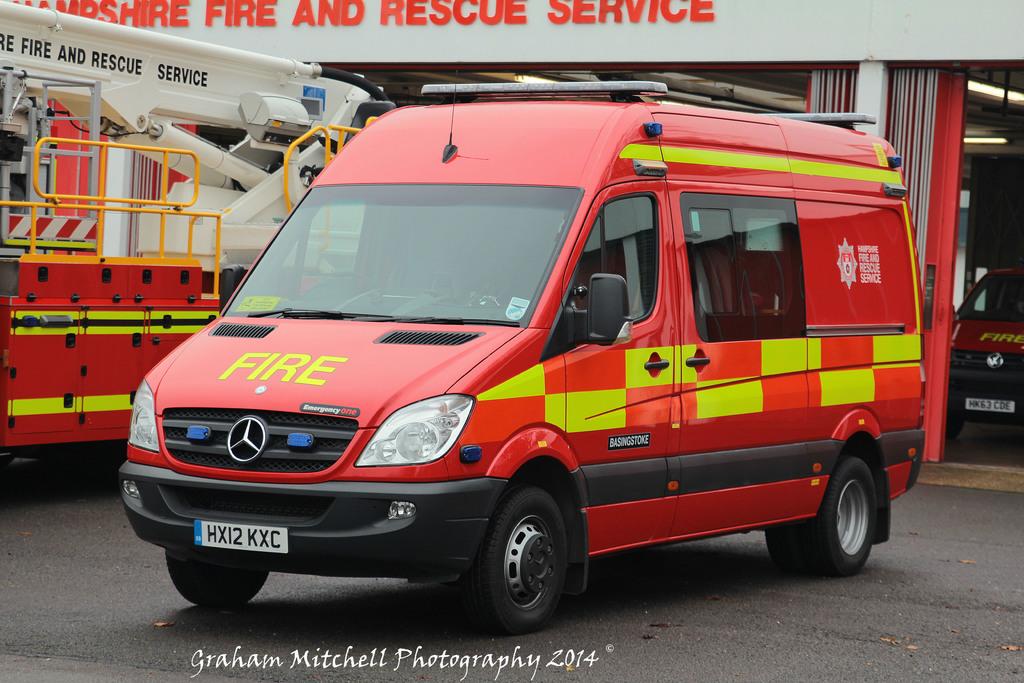What is on the hood of the van?
Ensure brevity in your answer.  Fire. What is written on the building?
Give a very brief answer. Fire and rescue service. 